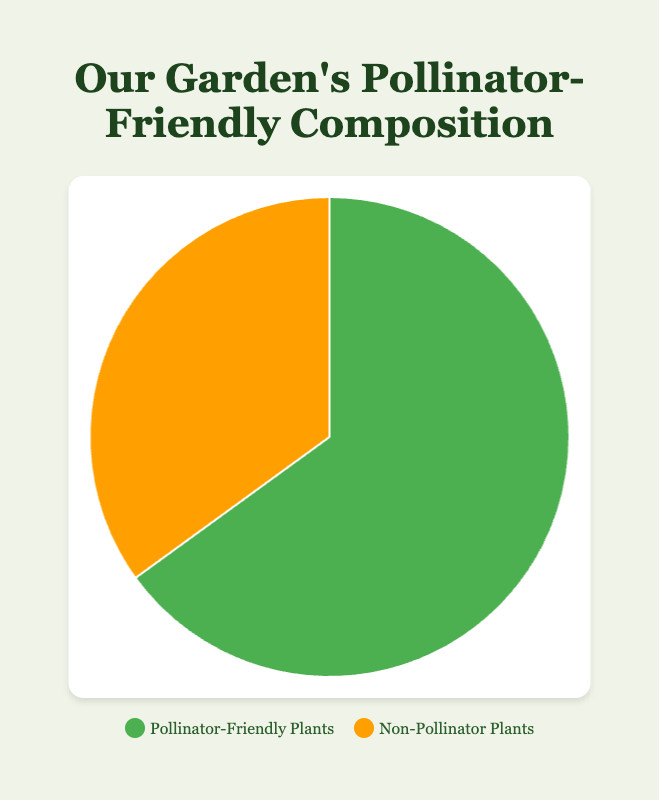What percentage of the garden is comprised of Pollinator-Friendly Plants? The chart shows two sections, one for Pollinator-Friendly Plants and one for Non-Pollinator Plants. The Pollinator-Friendly Plants section is 65%.
Answer: 65% What percentage of the garden is comprised of Non-Pollinator Plants? The chart shows that the Non-Pollinator Plants section is 35%.
Answer: 35% Which type of plants have a larger share in the garden, Pollinator-Friendly Plants or Non-Pollinator Plants? Comparing the percentages, Pollinator-Friendly Plants have 65% while Non-Pollinator Plants have 35%. Pollinator-Friendly Plants have a larger share.
Answer: Pollinator-Friendly Plants By what percentage is the share of Pollinator-Friendly Plants greater than Non-Pollinator Plants in the garden? The percentage share of Pollinator-Friendly Plants is 65% and Non-Pollinator Plants is 35%. The difference is 65% - 35% = 30%.
Answer: 30% What is the ratio of Pollinator-Friendly Plants to Non-Pollinator Plants? The percentage of Pollinator-Friendly Plants is 65%, and the percentage of Non-Pollinator Plants is 35%. The ratio is 65:35.
Answer: 65:35 What is the sum of the shares of Pollinator-Friendly Plants and Non-Pollinator Plants in the garden? The sum of the percentages is 65% + 35% = 100%.
Answer: 100% How much more percentage does Pollinator-Friendly Plants cover compared to Non-Pollinator Plants? The Pollinator-Friendly Plants cover 65% and Non-Pollinator Plants cover 35%. The difference is 65% - 35% = 30%.
Answer: 30% If the garden area is 1,000 square meters, how much area is occupied by Pollinator-Friendly Plants? If the total area is 1,000 square meters and Pollinator-Friendly Plants cover 65%, the area occupied by them is 1,000 * 0.65 = 650 square meters.
Answer: 650 square meters What are the colors used to distinguish Pollinator-Friendly Plants and Non-Pollinator Plants in the chart? The chart uses green for Pollinator-Friendly Plants and orange for Non-Pollinator Plants.
Answer: Green and Orange 